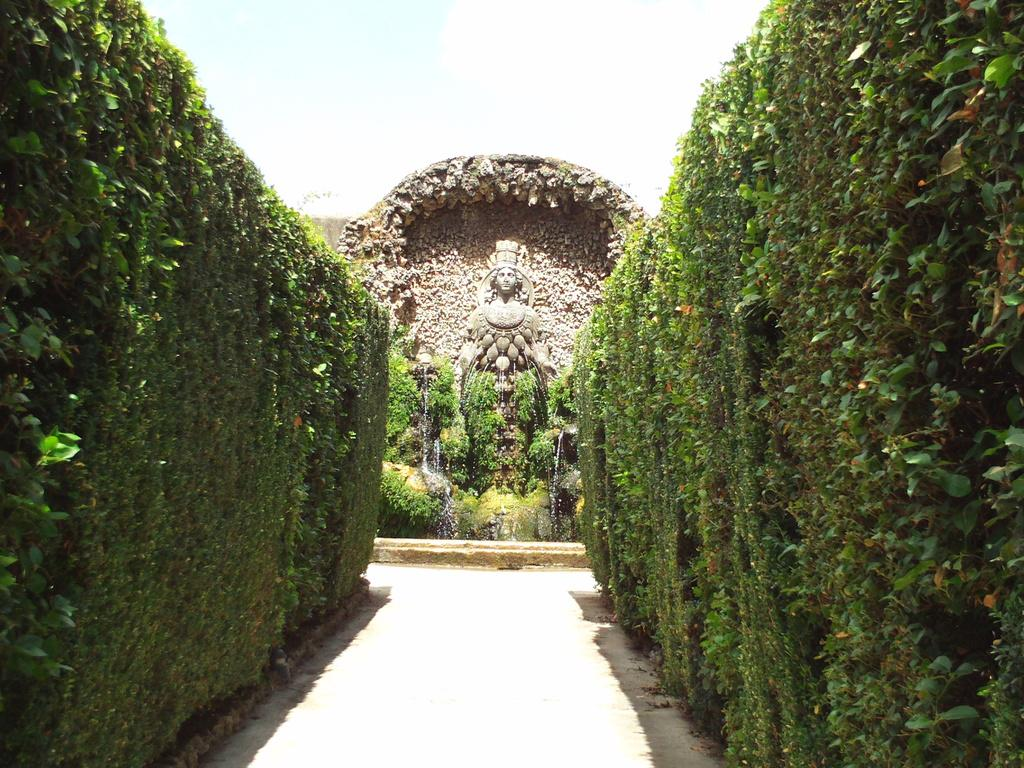What type of path is visible in the image? There is a walkway in the image. What is located on the walkway? There is a sculpture fountain on the walkway. What type of vegetation is present on both sides of the walkway? There are hedges on the left side and the right side of the walkway. What can be seen behind the sculpture in the image? The sky is visible behind the sculpture. What is the chance of a man riding a rail in the image? There is no man or rail present in the image, so it is not possible to determine the chance of such an event occurring. 